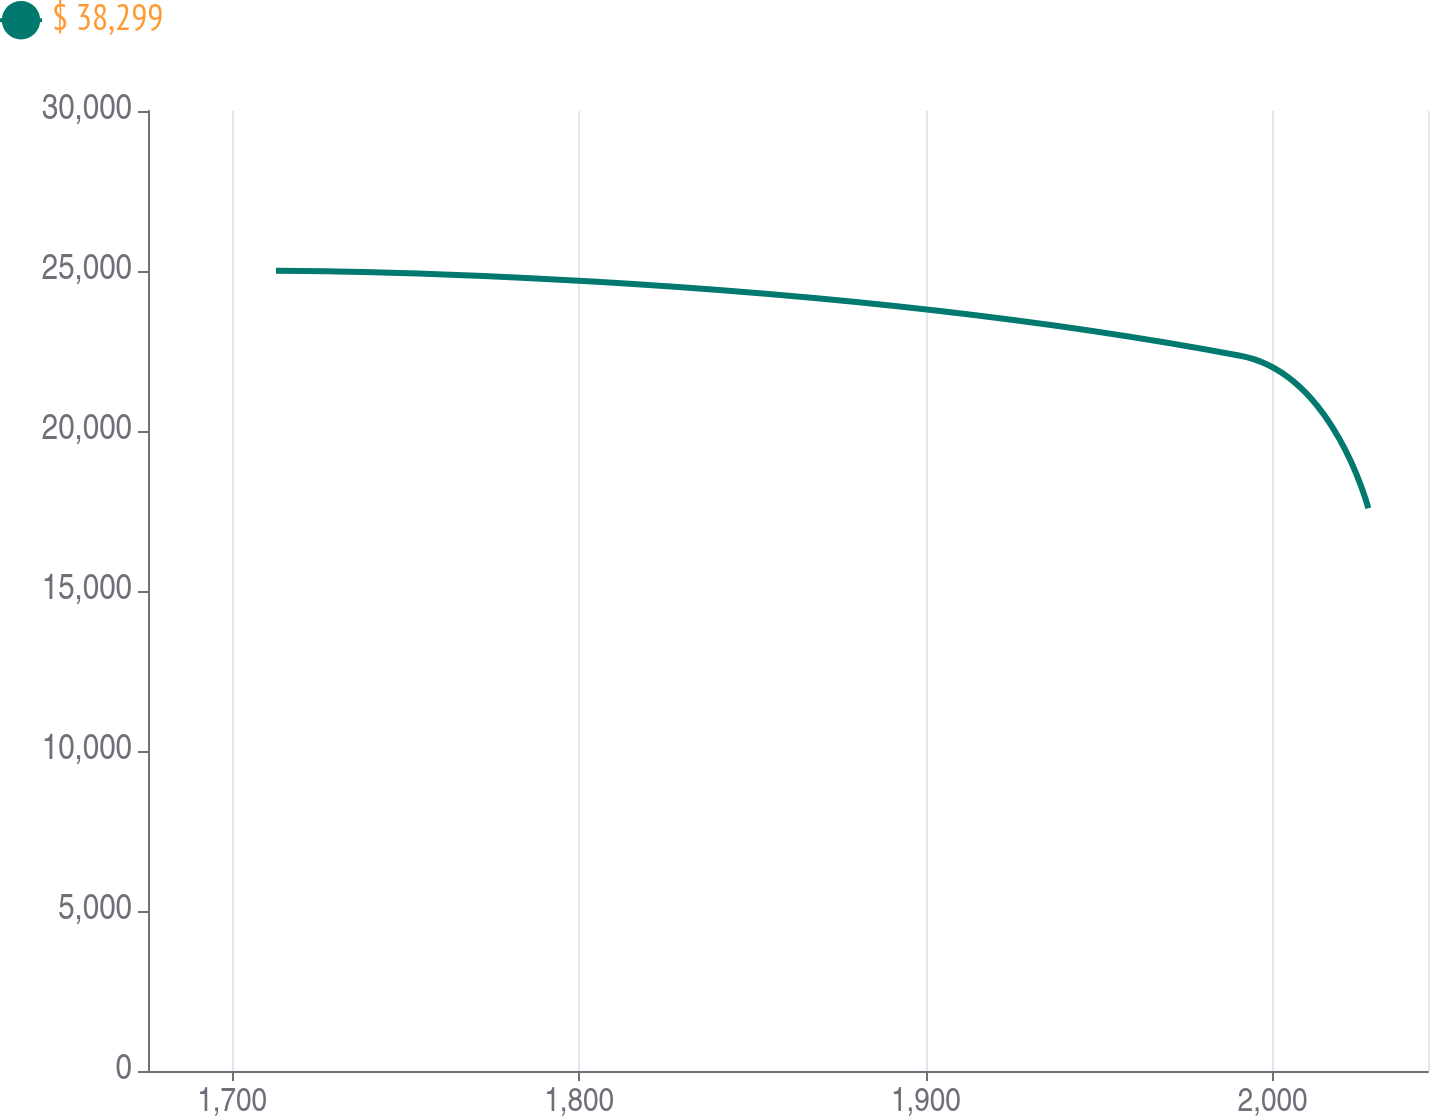Convert chart. <chart><loc_0><loc_0><loc_500><loc_500><line_chart><ecel><fcel>$ 38,299<nl><fcel>1712.62<fcel>25010.2<nl><fcel>1990.67<fcel>22350.5<nl><fcel>2027.58<fcel>17586.8<nl><fcel>2081.72<fcel>10770.7<nl></chart> 